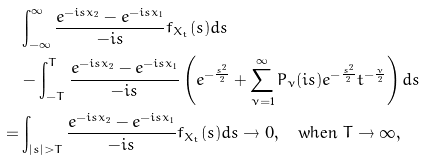<formula> <loc_0><loc_0><loc_500><loc_500>& \int _ { - \infty } ^ { \infty } \frac { e ^ { - i s x _ { 2 } } - e ^ { - i s x _ { 1 } } } { - i s } f _ { X _ { t } } ( s ) d s \\ & - \int _ { - T } ^ { T } \frac { e ^ { - i s x _ { 2 } } - e ^ { - i s x _ { 1 } } } { - i s } \left ( e ^ { - \frac { s ^ { 2 } } { 2 } } + \sum _ { \nu = 1 } ^ { \infty } P _ { \nu } ( i s ) e ^ { - \frac { s ^ { 2 } } { 2 } } t ^ { - \frac { \nu } { 2 } } \right ) d s \\ = & \int _ { | s | > T } \frac { e ^ { - i s x _ { 2 } } - e ^ { - i s x _ { 1 } } } { - i s } f _ { X _ { t } } ( s ) d s \rightarrow 0 , \quad \text {when } T \rightarrow \infty ,</formula> 